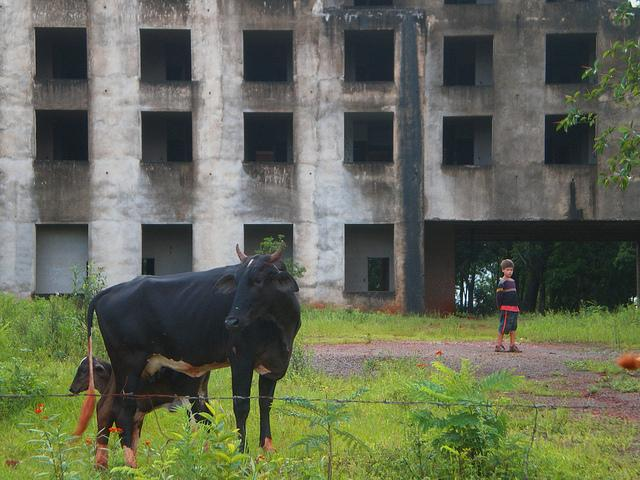What animals is the child looking at?

Choices:
A) cats
B) deer
C) beavers
D) cows cows 